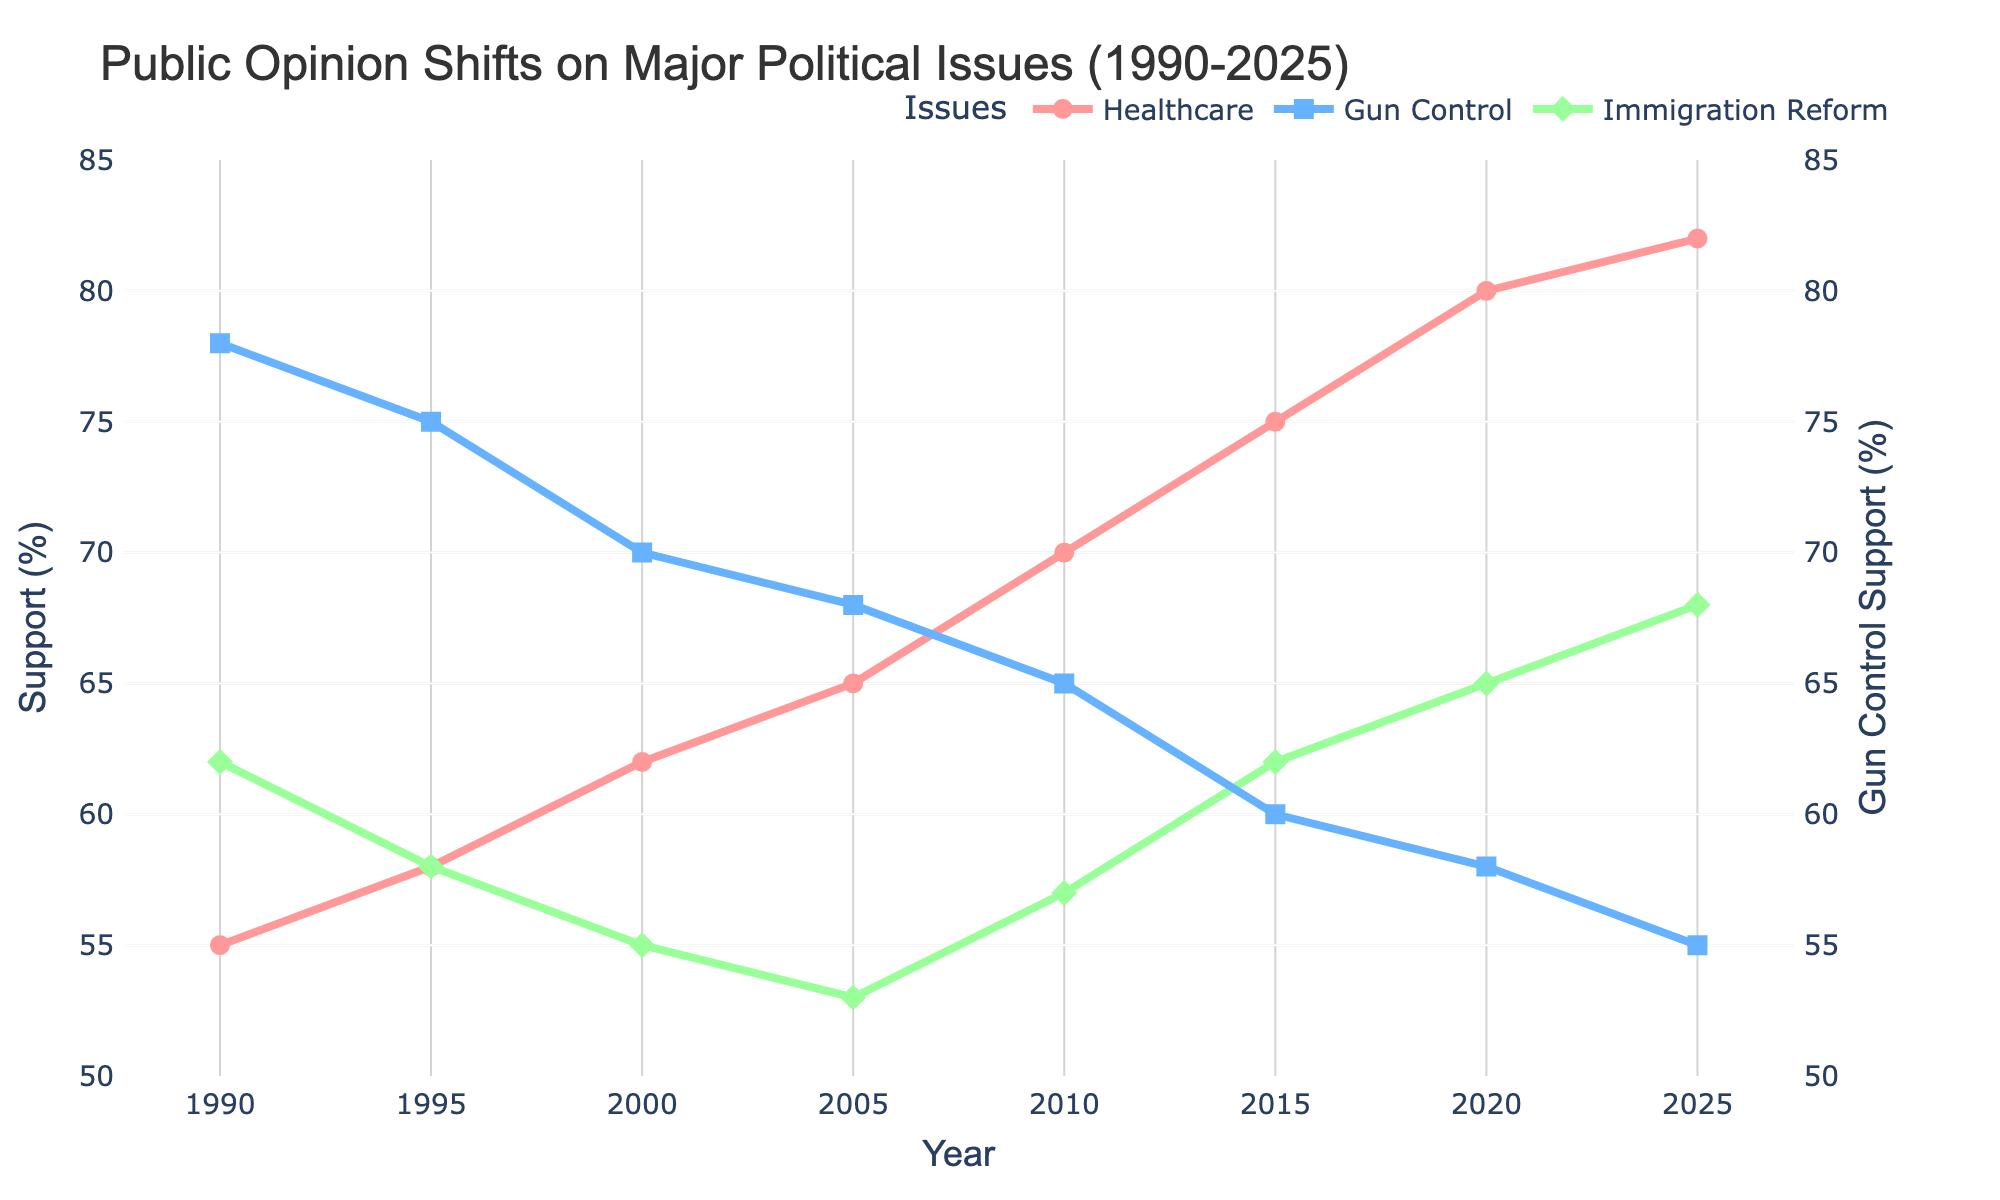How has support for healthcare changed from 1990 to 2025? To find this, look at the data points for healthcare support in 1990 and 2025. In 1990, support for healthcare was at 55%, and by 2025, it had increased to 82%.
Answer: Increased by 27% Which year had the lowest support for gun control? To determine the year with the lowest support for gun control, identify which data point has the smallest value. From the data, the lowest point is 55% in 2025.
Answer: 2025 Between 2005 and 2015, did support for immigration reform increase or decrease? Look at the values for immigration reform support in both 2005 and 2015. In 2005, it was 53%, and in 2015, it increased to 62%.
Answer: Increased What's the average support for healthcare over the three decades? To calculate the average, sum all the healthcare support values and divide by the number of data points: (55 + 58 + 62 + 65 + 70 + 75 + 80 + 82) / 8. The total is 547, so the average is 547 / 8.
Answer: 68.375% Which issue saw the highest increase in public support from 2000 to 2020? First, calculate the change for each issue between 2000 and 2020. For healthcare: 80 - 62 = 18, for gun control: 58 - 70 = -12, and for immigration reform: 65 - 55 = 10. The highest increase is for healthcare with 18%.
Answer: Healthcare By how many percentage points did support for gun control decrease from 2000 to 2020? Compare the values of gun control support from 2000 and 2020. In 2000, it was 70%, and in 2020, it dropped to 58%. Calculate the decrease: 70 - 58 = 12 points.
Answer: 12 points In which year did healthcare support surpass 70% for the first time? Identify the first data point where healthcare support exceeds 70%. Healthcare support reaches 70% in 2010.
Answer: 2010 Which issue had the most stable support (least variation) from 1990 to 2025? To determine stability, assess the variance or range of values for each issue over the years. Healthcare (55-82), Gun Control (55-78), Immigration Reform (53-68). Calculate the range for each and compare. Gun Control has the smallest range.
Answer: Gun Control Between 1995 and 2015, which political issue experienced the greatest decrease in public support? Compare the changes for each issue from 1995 to 2015. Healthcare increased (58 to 75), Gun Control decreased (75 to 60), Immigration Reform varied but went up again to 62. Gun Control experienced the greatest decrease: 75 - 60 = 15.
Answer: Gun Control What is the difference in support for immigration reform between 1990 and 2020? Look at the values for immigration support in 1990 and 2020. It's 62% in 1990 and 65% in 2020. Calculate the difference: 65 - 62 = 3.
Answer: 3% 